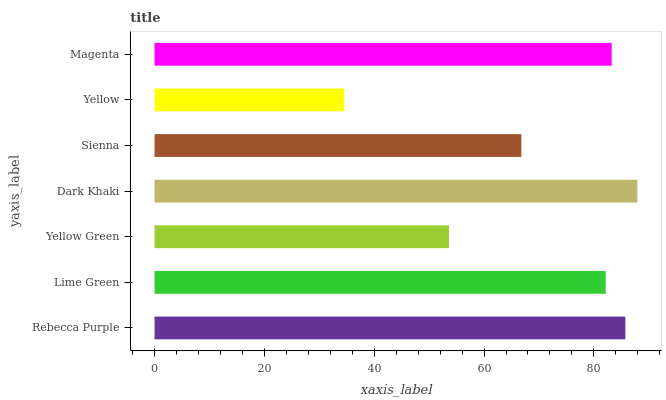Is Yellow the minimum?
Answer yes or no. Yes. Is Dark Khaki the maximum?
Answer yes or no. Yes. Is Lime Green the minimum?
Answer yes or no. No. Is Lime Green the maximum?
Answer yes or no. No. Is Rebecca Purple greater than Lime Green?
Answer yes or no. Yes. Is Lime Green less than Rebecca Purple?
Answer yes or no. Yes. Is Lime Green greater than Rebecca Purple?
Answer yes or no. No. Is Rebecca Purple less than Lime Green?
Answer yes or no. No. Is Lime Green the high median?
Answer yes or no. Yes. Is Lime Green the low median?
Answer yes or no. Yes. Is Sienna the high median?
Answer yes or no. No. Is Rebecca Purple the low median?
Answer yes or no. No. 